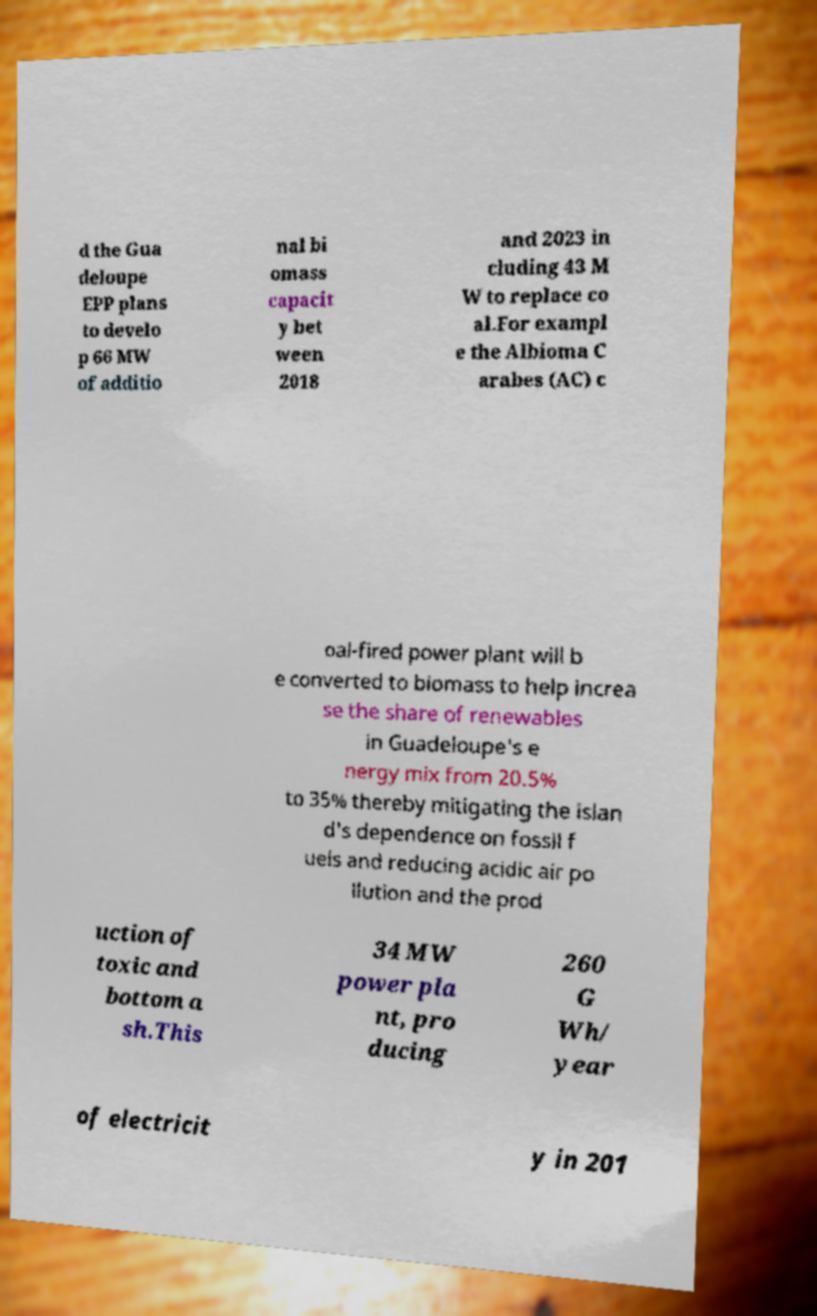I need the written content from this picture converted into text. Can you do that? d the Gua deloupe EPP plans to develo p 66 MW of additio nal bi omass capacit y bet ween 2018 and 2023 in cluding 43 M W to replace co al.For exampl e the Albioma C arabes (AC) c oal-fired power plant will b e converted to biomass to help increa se the share of renewables in Guadeloupe's e nergy mix from 20.5% to 35% thereby mitigating the islan d's dependence on fossil f uels and reducing acidic air po llution and the prod uction of toxic and bottom a sh.This 34 MW power pla nt, pro ducing 260 G Wh/ year of electricit y in 201 